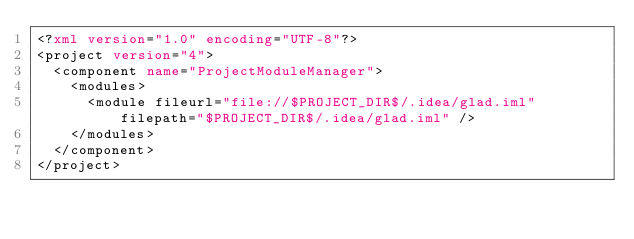<code> <loc_0><loc_0><loc_500><loc_500><_XML_><?xml version="1.0" encoding="UTF-8"?>
<project version="4">
  <component name="ProjectModuleManager">
    <modules>
      <module fileurl="file://$PROJECT_DIR$/.idea/glad.iml" filepath="$PROJECT_DIR$/.idea/glad.iml" />
    </modules>
  </component>
</project></code> 